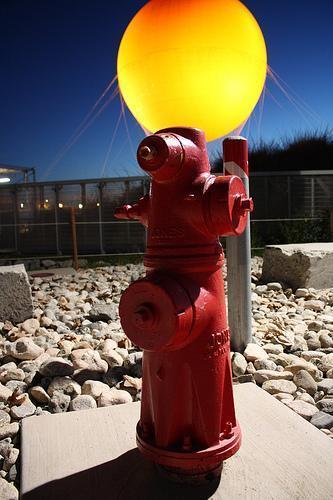How many balloons are shown?
Give a very brief answer. 1. 